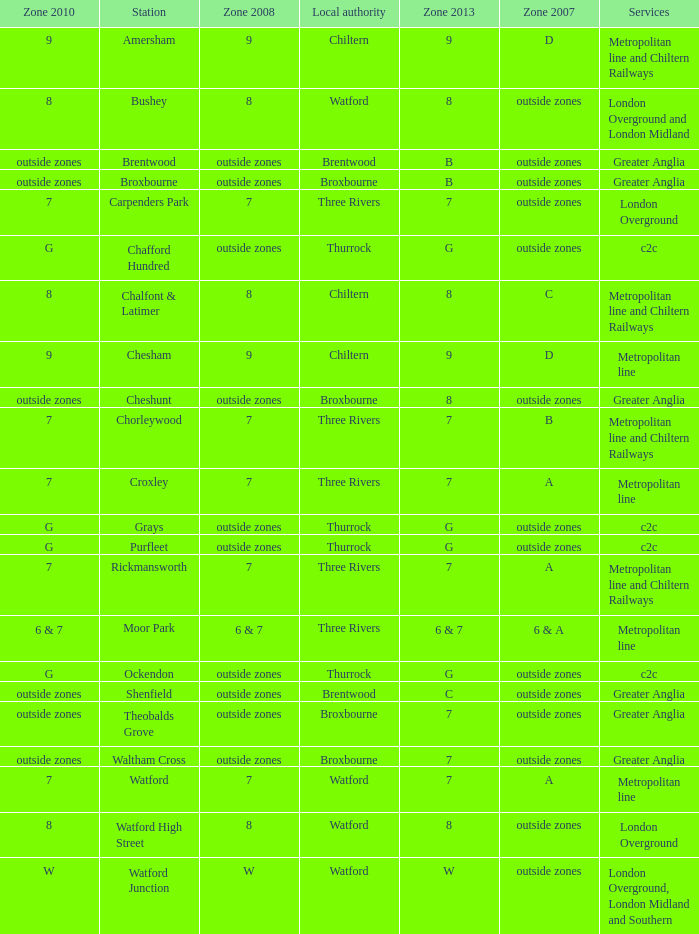Which Local authority has a Zone 2007 of outside zones, and a Zone 2008 of outside zones, and a Zone 2010 of outside zones, and a Station of waltham cross? Broxbourne. 